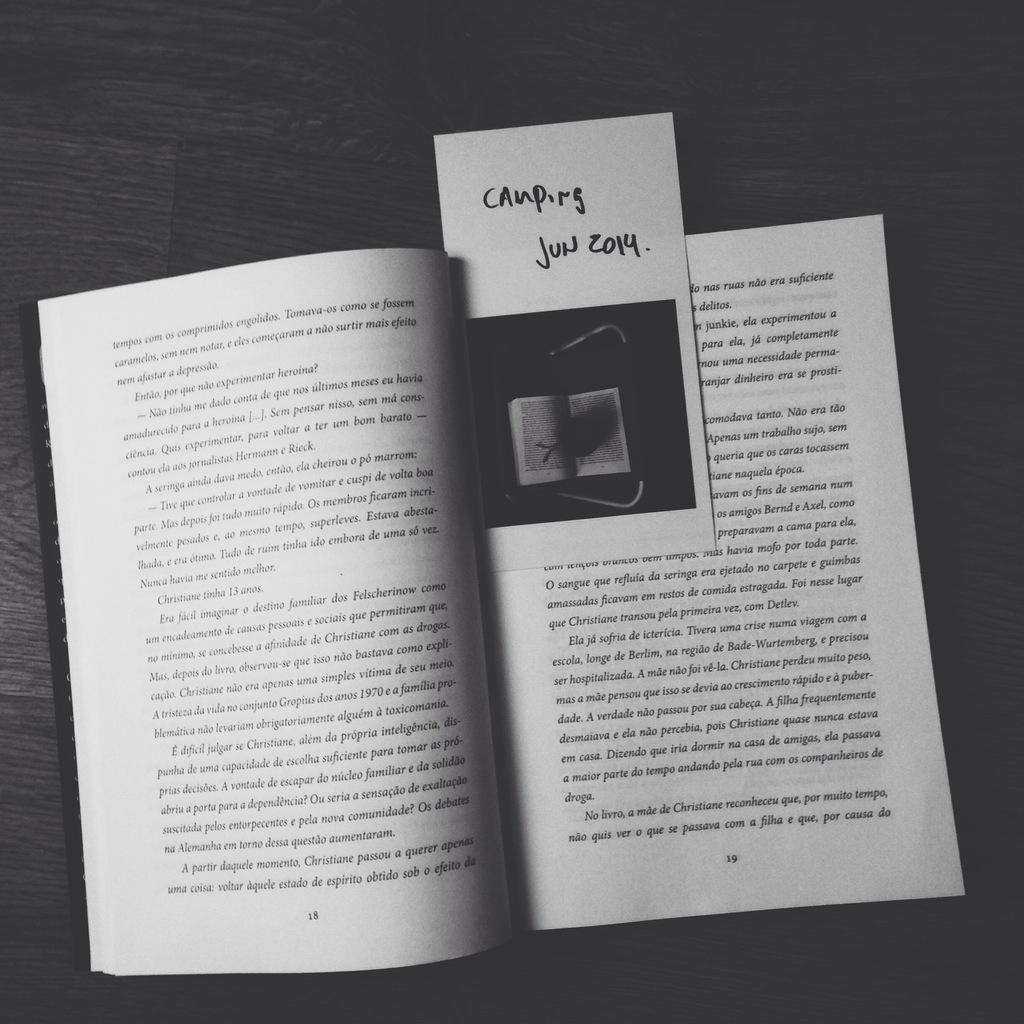<image>
Share a concise interpretation of the image provided. Book with a Bookmark on comping in June of 2014. 